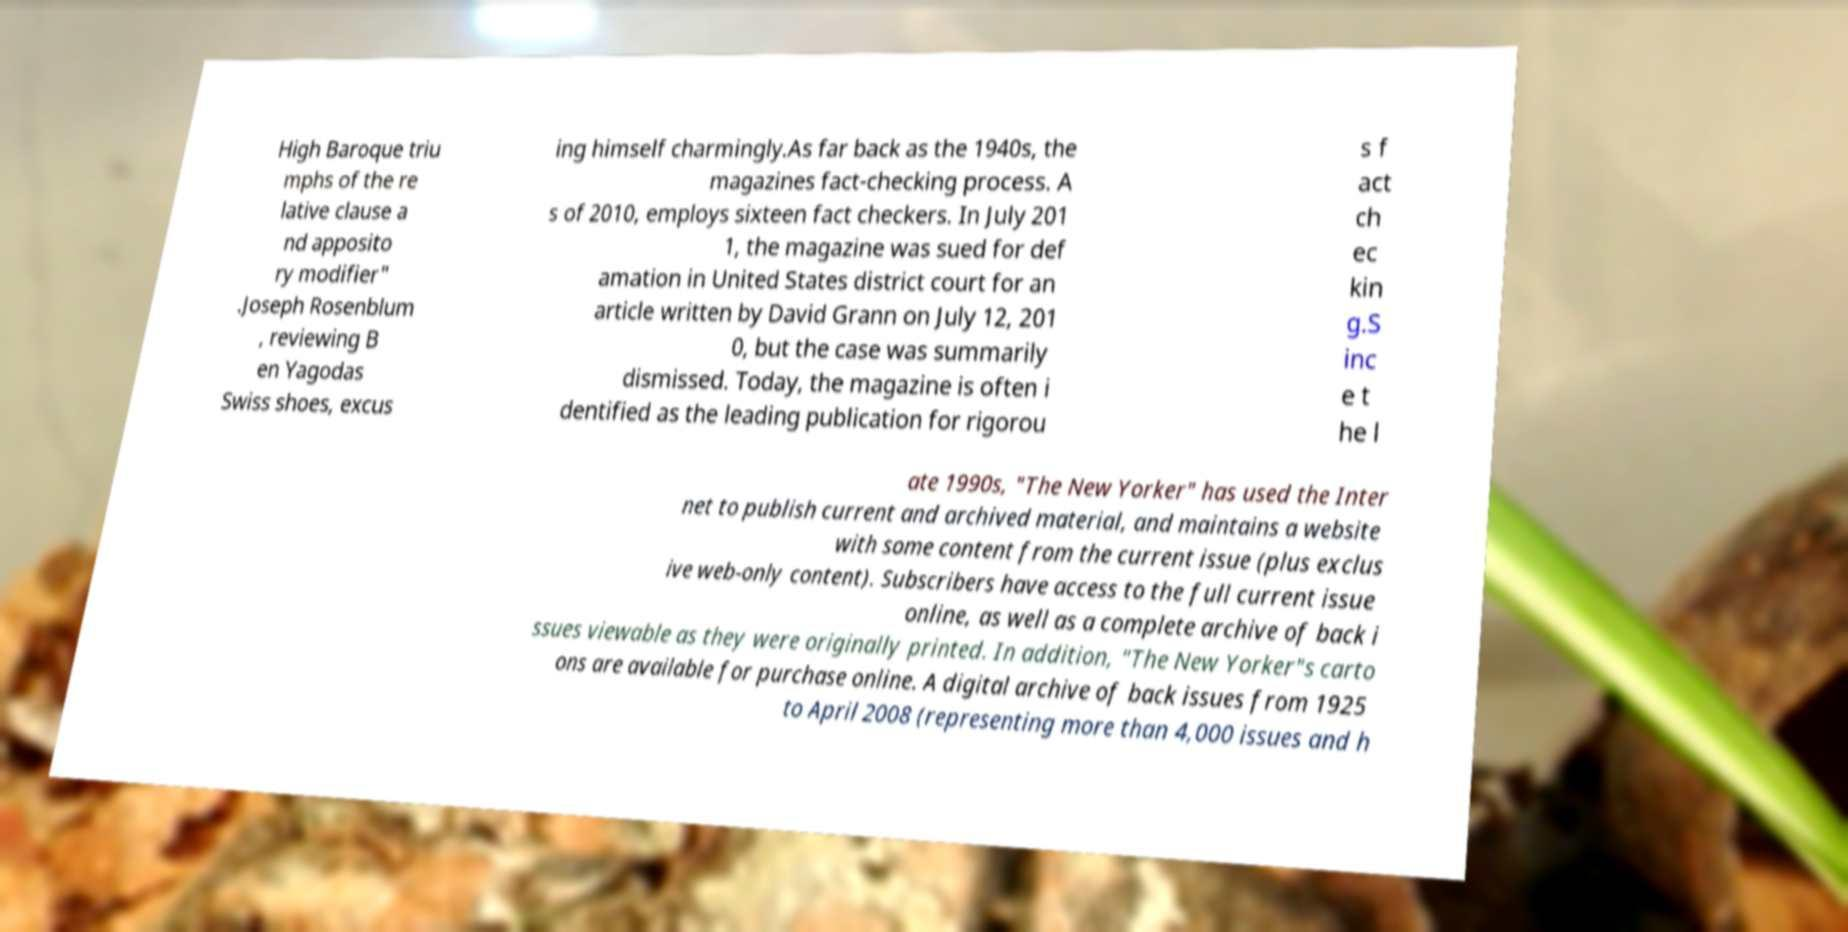Can you read and provide the text displayed in the image?This photo seems to have some interesting text. Can you extract and type it out for me? High Baroque triu mphs of the re lative clause a nd apposito ry modifier" .Joseph Rosenblum , reviewing B en Yagodas Swiss shoes, excus ing himself charmingly.As far back as the 1940s, the magazines fact-checking process. A s of 2010, employs sixteen fact checkers. In July 201 1, the magazine was sued for def amation in United States district court for an article written by David Grann on July 12, 201 0, but the case was summarily dismissed. Today, the magazine is often i dentified as the leading publication for rigorou s f act ch ec kin g.S inc e t he l ate 1990s, "The New Yorker" has used the Inter net to publish current and archived material, and maintains a website with some content from the current issue (plus exclus ive web-only content). Subscribers have access to the full current issue online, as well as a complete archive of back i ssues viewable as they were originally printed. In addition, "The New Yorker"s carto ons are available for purchase online. A digital archive of back issues from 1925 to April 2008 (representing more than 4,000 issues and h 